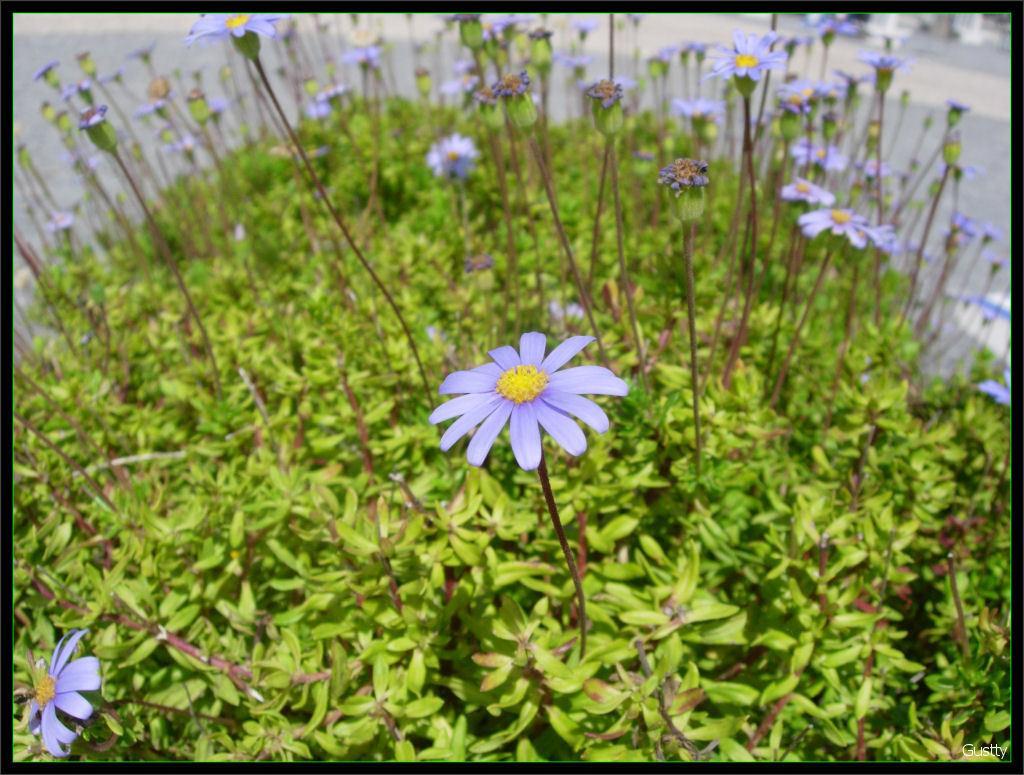How would you summarize this image in a sentence or two? In this image there are plants with the flowers on it. On the backside there is a road. 